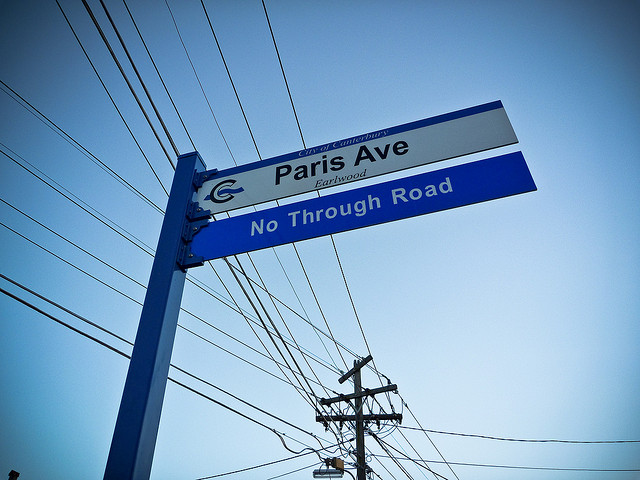Please identify all text content in this image. Paris Ave Earlwood No Through Road 